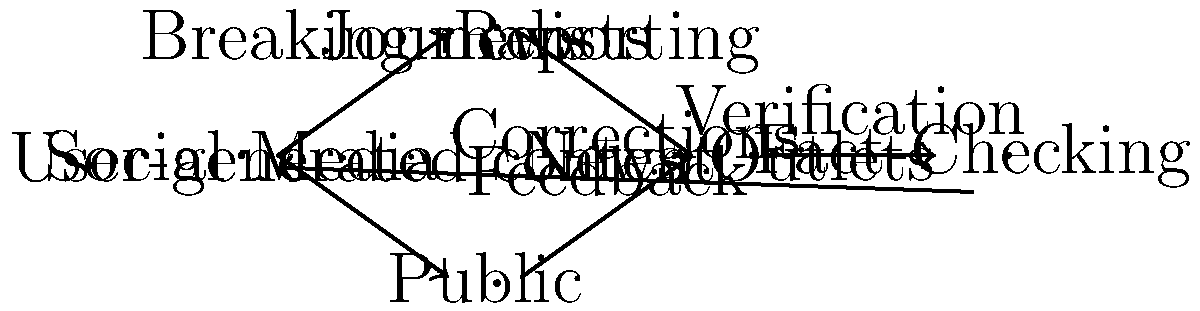In the flow diagram depicting the impact of social media on news dissemination, which crucial step is represented between "News Outlets" and "Social Media" that ensures the accuracy and reliability of information? To answer this question, let's analyze the flow diagram step-by-step:

1. The diagram starts with "Social Media" as the central node.
2. From "Social Media," there are two outgoing arrows:
   a. One to "Journalists" labeled "Breaking news"
   b. Another to "Public" labeled "User-generated content"
3. Both "Journalists" and "Public" have arrows pointing to "News Outlets":
   a. From "Journalists" to "News Outlets" labeled "Reporting"
   b. From "Public" to "News Outlets" labeled "Feedback"
4. From "News Outlets," there's an arrow pointing to "Fact-Checking" labeled "Verification"
5. Finally, there's an arrow from "Fact-Checking" back to "Social Media" labeled "Corrections"

The crucial step between "News Outlets" and "Social Media" that ensures accuracy and reliability is the "Fact-Checking" process. This step is vital because:

1. It verifies the information before it's disseminated widely on social media.
2. It helps correct any misinformation or inaccuracies in the original reporting.
3. It provides a feedback loop to improve the quality of information shared on social media platforms.

As a former international correspondent, you would recognize the importance of this step in maintaining journalistic integrity and providing accurate reporting to the public.
Answer: Fact-Checking 